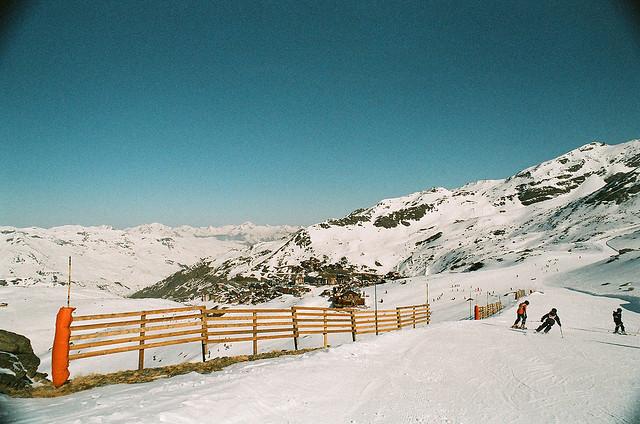What color is the fence?
Short answer required. Orange. Are they in the mountains?
Short answer required. Yes. Is the picture colored?
Be succinct. Yes. What sport are they participating in?
Give a very brief answer. Skiing. 